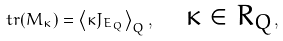Convert formula to latex. <formula><loc_0><loc_0><loc_500><loc_500>\ t r ( M _ { \kappa } ) = \left < \kappa J _ { E _ { Q } } \right > _ { Q } , \quad \text {$\kappa\in R_{Q}$} ,</formula> 